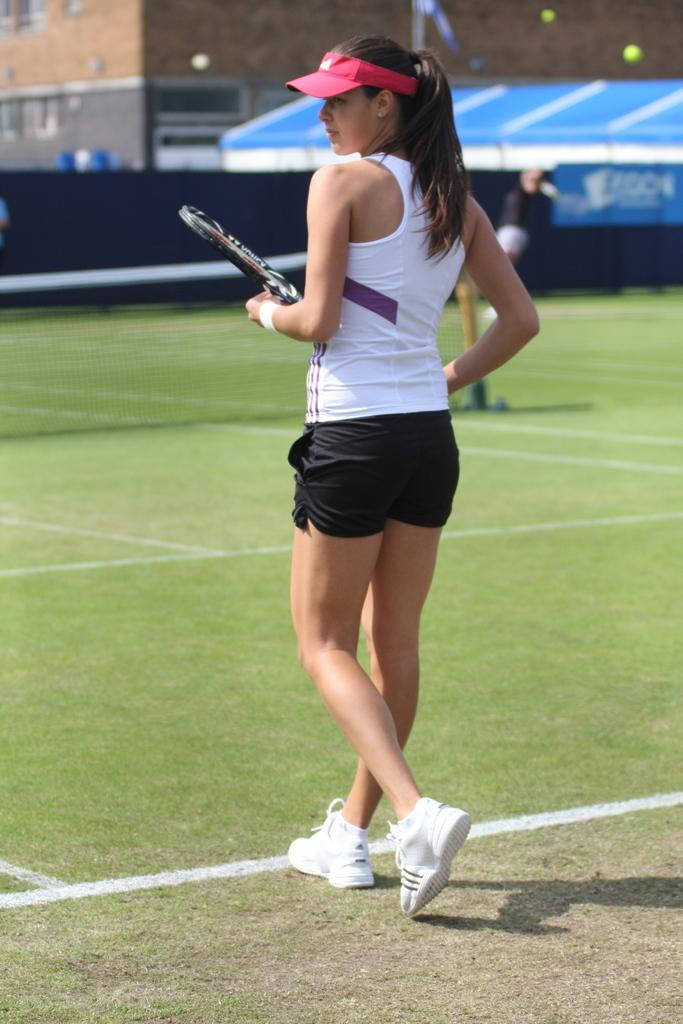Who is the main subject in the image? There is a woman in the image. What is the woman holding in the image? The woman is holding a tennis racket. What can be seen in the background of the image? There is a wall, a person, a net, and buildings in the background of the image. What is the color of the grass in the image? The grass in the bottom of the image is green in color. What type of spy equipment can be seen in the woman's hand in the image? There is no spy equipment visible in the woman's hand in the image; she is holding a tennis racket. How many slaves are present in the image? There are no slaves present in the image. 